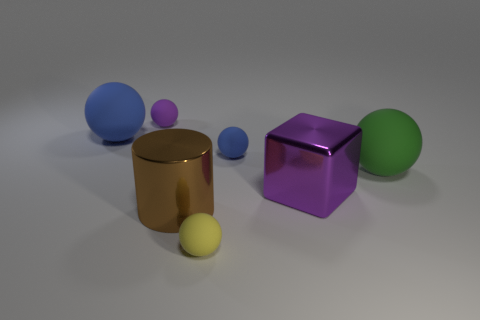Subtract 1 balls. How many balls are left? 4 Subtract all purple balls. How many balls are left? 4 Subtract all tiny blue balls. How many balls are left? 4 Subtract all red spheres. Subtract all purple cylinders. How many spheres are left? 5 Add 2 green matte spheres. How many objects exist? 9 Subtract all balls. How many objects are left? 2 Add 3 purple rubber things. How many purple rubber things are left? 4 Add 1 large cyan metal spheres. How many large cyan metal spheres exist? 1 Subtract 0 green cylinders. How many objects are left? 7 Subtract all balls. Subtract all purple metal blocks. How many objects are left? 1 